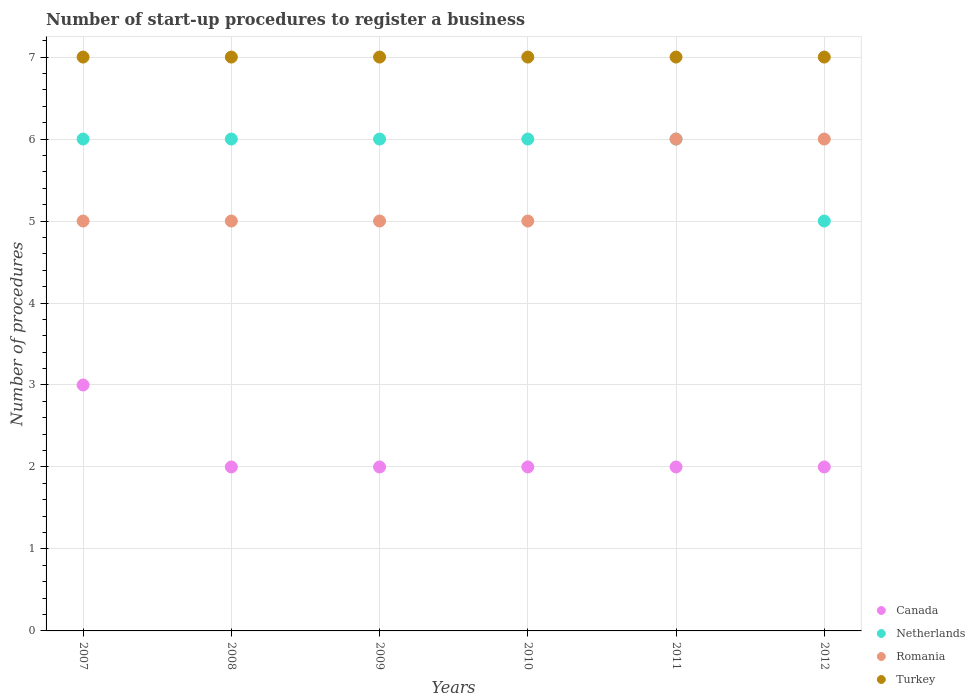How many different coloured dotlines are there?
Your answer should be very brief. 4. What is the number of procedures required to register a business in Netherlands in 2012?
Your answer should be very brief. 5. Across all years, what is the maximum number of procedures required to register a business in Canada?
Provide a succinct answer. 3. Across all years, what is the minimum number of procedures required to register a business in Canada?
Offer a terse response. 2. What is the total number of procedures required to register a business in Canada in the graph?
Keep it short and to the point. 13. What is the difference between the number of procedures required to register a business in Netherlands in 2008 and that in 2010?
Keep it short and to the point. 0. What is the difference between the number of procedures required to register a business in Romania in 2010 and the number of procedures required to register a business in Canada in 2008?
Offer a very short reply. 3. What is the average number of procedures required to register a business in Romania per year?
Ensure brevity in your answer.  5.33. In the year 2007, what is the difference between the number of procedures required to register a business in Netherlands and number of procedures required to register a business in Romania?
Provide a short and direct response. 1. In how many years, is the number of procedures required to register a business in Romania greater than 3.2?
Make the answer very short. 6. What is the ratio of the number of procedures required to register a business in Turkey in 2009 to that in 2012?
Your answer should be compact. 1. Is the number of procedures required to register a business in Romania in 2009 less than that in 2011?
Offer a terse response. Yes. Is the difference between the number of procedures required to register a business in Netherlands in 2009 and 2011 greater than the difference between the number of procedures required to register a business in Romania in 2009 and 2011?
Your answer should be very brief. Yes. What is the difference between the highest and the second highest number of procedures required to register a business in Turkey?
Make the answer very short. 0. What is the difference between the highest and the lowest number of procedures required to register a business in Canada?
Provide a short and direct response. 1. In how many years, is the number of procedures required to register a business in Canada greater than the average number of procedures required to register a business in Canada taken over all years?
Offer a terse response. 1. Is it the case that in every year, the sum of the number of procedures required to register a business in Romania and number of procedures required to register a business in Netherlands  is greater than the sum of number of procedures required to register a business in Turkey and number of procedures required to register a business in Canada?
Make the answer very short. No. Does the number of procedures required to register a business in Netherlands monotonically increase over the years?
Give a very brief answer. No. How many years are there in the graph?
Your answer should be very brief. 6. Are the values on the major ticks of Y-axis written in scientific E-notation?
Ensure brevity in your answer.  No. Does the graph contain any zero values?
Keep it short and to the point. No. Does the graph contain grids?
Your answer should be very brief. Yes. What is the title of the graph?
Give a very brief answer. Number of start-up procedures to register a business. Does "Congo (Republic)" appear as one of the legend labels in the graph?
Offer a very short reply. No. What is the label or title of the Y-axis?
Keep it short and to the point. Number of procedures. What is the Number of procedures in Netherlands in 2007?
Your answer should be very brief. 6. What is the Number of procedures in Turkey in 2007?
Offer a very short reply. 7. What is the Number of procedures of Canada in 2008?
Provide a succinct answer. 2. What is the Number of procedures of Turkey in 2008?
Make the answer very short. 7. What is the Number of procedures in Canada in 2009?
Ensure brevity in your answer.  2. What is the Number of procedures of Romania in 2009?
Give a very brief answer. 5. What is the Number of procedures of Romania in 2010?
Give a very brief answer. 5. What is the Number of procedures of Romania in 2011?
Make the answer very short. 6. What is the Number of procedures of Netherlands in 2012?
Provide a succinct answer. 5. Across all years, what is the maximum Number of procedures in Canada?
Your response must be concise. 3. Across all years, what is the maximum Number of procedures of Netherlands?
Your answer should be compact. 6. Across all years, what is the maximum Number of procedures in Romania?
Offer a terse response. 6. Across all years, what is the minimum Number of procedures of Canada?
Give a very brief answer. 2. Across all years, what is the minimum Number of procedures in Netherlands?
Your response must be concise. 5. Across all years, what is the minimum Number of procedures of Turkey?
Your response must be concise. 7. What is the total Number of procedures in Romania in the graph?
Your answer should be very brief. 32. What is the total Number of procedures of Turkey in the graph?
Your answer should be compact. 42. What is the difference between the Number of procedures in Romania in 2007 and that in 2008?
Your response must be concise. 0. What is the difference between the Number of procedures of Canada in 2007 and that in 2009?
Your answer should be very brief. 1. What is the difference between the Number of procedures of Netherlands in 2007 and that in 2009?
Ensure brevity in your answer.  0. What is the difference between the Number of procedures of Canada in 2007 and that in 2010?
Your answer should be very brief. 1. What is the difference between the Number of procedures of Romania in 2007 and that in 2010?
Provide a short and direct response. 0. What is the difference between the Number of procedures of Turkey in 2007 and that in 2010?
Make the answer very short. 0. What is the difference between the Number of procedures of Canada in 2007 and that in 2011?
Give a very brief answer. 1. What is the difference between the Number of procedures in Romania in 2007 and that in 2011?
Your answer should be very brief. -1. What is the difference between the Number of procedures in Canada in 2007 and that in 2012?
Offer a terse response. 1. What is the difference between the Number of procedures in Canada in 2008 and that in 2009?
Ensure brevity in your answer.  0. What is the difference between the Number of procedures of Romania in 2008 and that in 2009?
Provide a succinct answer. 0. What is the difference between the Number of procedures in Turkey in 2008 and that in 2009?
Keep it short and to the point. 0. What is the difference between the Number of procedures of Romania in 2008 and that in 2010?
Keep it short and to the point. 0. What is the difference between the Number of procedures in Canada in 2008 and that in 2011?
Your response must be concise. 0. What is the difference between the Number of procedures of Netherlands in 2008 and that in 2011?
Provide a short and direct response. 0. What is the difference between the Number of procedures in Canada in 2009 and that in 2010?
Your answer should be compact. 0. What is the difference between the Number of procedures of Turkey in 2009 and that in 2010?
Provide a succinct answer. 0. What is the difference between the Number of procedures in Canada in 2009 and that in 2011?
Offer a very short reply. 0. What is the difference between the Number of procedures in Netherlands in 2009 and that in 2011?
Offer a very short reply. 0. What is the difference between the Number of procedures of Romania in 2009 and that in 2011?
Your answer should be compact. -1. What is the difference between the Number of procedures of Turkey in 2009 and that in 2011?
Offer a terse response. 0. What is the difference between the Number of procedures of Canada in 2009 and that in 2012?
Offer a very short reply. 0. What is the difference between the Number of procedures of Netherlands in 2009 and that in 2012?
Ensure brevity in your answer.  1. What is the difference between the Number of procedures of Canada in 2010 and that in 2011?
Ensure brevity in your answer.  0. What is the difference between the Number of procedures in Romania in 2010 and that in 2011?
Make the answer very short. -1. What is the difference between the Number of procedures of Canada in 2010 and that in 2012?
Ensure brevity in your answer.  0. What is the difference between the Number of procedures of Romania in 2010 and that in 2012?
Offer a terse response. -1. What is the difference between the Number of procedures in Romania in 2011 and that in 2012?
Your answer should be compact. 0. What is the difference between the Number of procedures of Canada in 2007 and the Number of procedures of Turkey in 2008?
Provide a succinct answer. -4. What is the difference between the Number of procedures of Netherlands in 2007 and the Number of procedures of Romania in 2008?
Your answer should be compact. 1. What is the difference between the Number of procedures of Canada in 2007 and the Number of procedures of Romania in 2009?
Give a very brief answer. -2. What is the difference between the Number of procedures of Netherlands in 2007 and the Number of procedures of Romania in 2009?
Provide a succinct answer. 1. What is the difference between the Number of procedures in Netherlands in 2007 and the Number of procedures in Turkey in 2009?
Your answer should be very brief. -1. What is the difference between the Number of procedures of Canada in 2007 and the Number of procedures of Netherlands in 2010?
Offer a terse response. -3. What is the difference between the Number of procedures of Netherlands in 2007 and the Number of procedures of Romania in 2010?
Keep it short and to the point. 1. What is the difference between the Number of procedures of Romania in 2007 and the Number of procedures of Turkey in 2010?
Keep it short and to the point. -2. What is the difference between the Number of procedures in Canada in 2007 and the Number of procedures in Netherlands in 2011?
Provide a short and direct response. -3. What is the difference between the Number of procedures in Canada in 2007 and the Number of procedures in Romania in 2011?
Provide a succinct answer. -3. What is the difference between the Number of procedures in Canada in 2007 and the Number of procedures in Turkey in 2011?
Your answer should be very brief. -4. What is the difference between the Number of procedures in Netherlands in 2007 and the Number of procedures in Turkey in 2011?
Make the answer very short. -1. What is the difference between the Number of procedures in Romania in 2007 and the Number of procedures in Turkey in 2011?
Keep it short and to the point. -2. What is the difference between the Number of procedures in Canada in 2007 and the Number of procedures in Netherlands in 2012?
Your response must be concise. -2. What is the difference between the Number of procedures of Canada in 2007 and the Number of procedures of Romania in 2012?
Make the answer very short. -3. What is the difference between the Number of procedures of Netherlands in 2007 and the Number of procedures of Romania in 2012?
Offer a very short reply. 0. What is the difference between the Number of procedures in Romania in 2007 and the Number of procedures in Turkey in 2012?
Ensure brevity in your answer.  -2. What is the difference between the Number of procedures in Canada in 2008 and the Number of procedures in Romania in 2009?
Ensure brevity in your answer.  -3. What is the difference between the Number of procedures in Netherlands in 2008 and the Number of procedures in Romania in 2009?
Offer a very short reply. 1. What is the difference between the Number of procedures of Netherlands in 2008 and the Number of procedures of Turkey in 2009?
Offer a very short reply. -1. What is the difference between the Number of procedures of Romania in 2008 and the Number of procedures of Turkey in 2009?
Keep it short and to the point. -2. What is the difference between the Number of procedures in Netherlands in 2008 and the Number of procedures in Romania in 2010?
Ensure brevity in your answer.  1. What is the difference between the Number of procedures in Netherlands in 2008 and the Number of procedures in Turkey in 2010?
Keep it short and to the point. -1. What is the difference between the Number of procedures in Romania in 2008 and the Number of procedures in Turkey in 2010?
Your response must be concise. -2. What is the difference between the Number of procedures of Canada in 2008 and the Number of procedures of Netherlands in 2011?
Keep it short and to the point. -4. What is the difference between the Number of procedures of Canada in 2008 and the Number of procedures of Romania in 2011?
Your response must be concise. -4. What is the difference between the Number of procedures of Canada in 2008 and the Number of procedures of Turkey in 2011?
Provide a short and direct response. -5. What is the difference between the Number of procedures in Romania in 2008 and the Number of procedures in Turkey in 2011?
Provide a short and direct response. -2. What is the difference between the Number of procedures in Netherlands in 2008 and the Number of procedures in Romania in 2012?
Your answer should be compact. 0. What is the difference between the Number of procedures of Netherlands in 2008 and the Number of procedures of Turkey in 2012?
Provide a short and direct response. -1. What is the difference between the Number of procedures of Canada in 2009 and the Number of procedures of Netherlands in 2010?
Ensure brevity in your answer.  -4. What is the difference between the Number of procedures in Canada in 2009 and the Number of procedures in Romania in 2010?
Offer a terse response. -3. What is the difference between the Number of procedures of Canada in 2009 and the Number of procedures of Netherlands in 2011?
Offer a terse response. -4. What is the difference between the Number of procedures in Canada in 2009 and the Number of procedures in Romania in 2011?
Your answer should be very brief. -4. What is the difference between the Number of procedures in Netherlands in 2009 and the Number of procedures in Turkey in 2011?
Your answer should be very brief. -1. What is the difference between the Number of procedures of Canada in 2009 and the Number of procedures of Romania in 2012?
Make the answer very short. -4. What is the difference between the Number of procedures in Netherlands in 2009 and the Number of procedures in Romania in 2012?
Provide a succinct answer. 0. What is the difference between the Number of procedures of Canada in 2010 and the Number of procedures of Netherlands in 2011?
Offer a very short reply. -4. What is the difference between the Number of procedures in Canada in 2010 and the Number of procedures in Romania in 2011?
Your answer should be very brief. -4. What is the difference between the Number of procedures of Romania in 2010 and the Number of procedures of Turkey in 2011?
Offer a terse response. -2. What is the difference between the Number of procedures in Canada in 2010 and the Number of procedures in Romania in 2012?
Your response must be concise. -4. What is the difference between the Number of procedures of Netherlands in 2010 and the Number of procedures of Turkey in 2012?
Offer a terse response. -1. What is the difference between the Number of procedures in Canada in 2011 and the Number of procedures in Netherlands in 2012?
Give a very brief answer. -3. What is the difference between the Number of procedures in Canada in 2011 and the Number of procedures in Romania in 2012?
Offer a very short reply. -4. What is the difference between the Number of procedures of Netherlands in 2011 and the Number of procedures of Turkey in 2012?
Your response must be concise. -1. What is the average Number of procedures of Canada per year?
Provide a short and direct response. 2.17. What is the average Number of procedures in Netherlands per year?
Your answer should be compact. 5.83. What is the average Number of procedures in Romania per year?
Offer a terse response. 5.33. In the year 2007, what is the difference between the Number of procedures of Canada and Number of procedures of Netherlands?
Provide a succinct answer. -3. In the year 2007, what is the difference between the Number of procedures in Netherlands and Number of procedures in Romania?
Offer a terse response. 1. In the year 2007, what is the difference between the Number of procedures in Netherlands and Number of procedures in Turkey?
Keep it short and to the point. -1. In the year 2007, what is the difference between the Number of procedures of Romania and Number of procedures of Turkey?
Provide a succinct answer. -2. In the year 2008, what is the difference between the Number of procedures in Netherlands and Number of procedures in Romania?
Your response must be concise. 1. In the year 2009, what is the difference between the Number of procedures in Canada and Number of procedures in Netherlands?
Your answer should be very brief. -4. In the year 2009, what is the difference between the Number of procedures of Canada and Number of procedures of Romania?
Ensure brevity in your answer.  -3. In the year 2009, what is the difference between the Number of procedures in Canada and Number of procedures in Turkey?
Ensure brevity in your answer.  -5. In the year 2009, what is the difference between the Number of procedures in Netherlands and Number of procedures in Romania?
Your response must be concise. 1. In the year 2009, what is the difference between the Number of procedures of Netherlands and Number of procedures of Turkey?
Your answer should be very brief. -1. In the year 2009, what is the difference between the Number of procedures in Romania and Number of procedures in Turkey?
Your answer should be very brief. -2. In the year 2010, what is the difference between the Number of procedures in Canada and Number of procedures in Romania?
Keep it short and to the point. -3. In the year 2010, what is the difference between the Number of procedures of Canada and Number of procedures of Turkey?
Offer a terse response. -5. In the year 2010, what is the difference between the Number of procedures of Netherlands and Number of procedures of Romania?
Make the answer very short. 1. In the year 2010, what is the difference between the Number of procedures of Netherlands and Number of procedures of Turkey?
Make the answer very short. -1. In the year 2010, what is the difference between the Number of procedures of Romania and Number of procedures of Turkey?
Ensure brevity in your answer.  -2. In the year 2011, what is the difference between the Number of procedures of Canada and Number of procedures of Netherlands?
Your answer should be very brief. -4. In the year 2011, what is the difference between the Number of procedures in Canada and Number of procedures in Romania?
Keep it short and to the point. -4. In the year 2011, what is the difference between the Number of procedures of Netherlands and Number of procedures of Romania?
Provide a short and direct response. 0. In the year 2011, what is the difference between the Number of procedures in Netherlands and Number of procedures in Turkey?
Offer a very short reply. -1. In the year 2012, what is the difference between the Number of procedures in Canada and Number of procedures in Romania?
Offer a terse response. -4. In the year 2012, what is the difference between the Number of procedures of Canada and Number of procedures of Turkey?
Offer a terse response. -5. In the year 2012, what is the difference between the Number of procedures in Netherlands and Number of procedures in Romania?
Ensure brevity in your answer.  -1. In the year 2012, what is the difference between the Number of procedures of Netherlands and Number of procedures of Turkey?
Keep it short and to the point. -2. In the year 2012, what is the difference between the Number of procedures in Romania and Number of procedures in Turkey?
Provide a short and direct response. -1. What is the ratio of the Number of procedures of Netherlands in 2007 to that in 2008?
Your answer should be very brief. 1. What is the ratio of the Number of procedures of Turkey in 2007 to that in 2008?
Make the answer very short. 1. What is the ratio of the Number of procedures of Netherlands in 2007 to that in 2009?
Offer a very short reply. 1. What is the ratio of the Number of procedures in Romania in 2007 to that in 2009?
Your answer should be very brief. 1. What is the ratio of the Number of procedures of Romania in 2007 to that in 2010?
Your answer should be very brief. 1. What is the ratio of the Number of procedures of Canada in 2007 to that in 2011?
Provide a succinct answer. 1.5. What is the ratio of the Number of procedures of Netherlands in 2007 to that in 2011?
Your answer should be compact. 1. What is the ratio of the Number of procedures of Canada in 2007 to that in 2012?
Provide a short and direct response. 1.5. What is the ratio of the Number of procedures of Netherlands in 2007 to that in 2012?
Keep it short and to the point. 1.2. What is the ratio of the Number of procedures in Romania in 2007 to that in 2012?
Ensure brevity in your answer.  0.83. What is the ratio of the Number of procedures in Netherlands in 2008 to that in 2009?
Give a very brief answer. 1. What is the ratio of the Number of procedures of Turkey in 2008 to that in 2010?
Give a very brief answer. 1. What is the ratio of the Number of procedures in Romania in 2008 to that in 2011?
Provide a short and direct response. 0.83. What is the ratio of the Number of procedures of Turkey in 2008 to that in 2011?
Make the answer very short. 1. What is the ratio of the Number of procedures of Canada in 2008 to that in 2012?
Offer a terse response. 1. What is the ratio of the Number of procedures of Netherlands in 2008 to that in 2012?
Provide a succinct answer. 1.2. What is the ratio of the Number of procedures of Turkey in 2008 to that in 2012?
Your answer should be compact. 1. What is the ratio of the Number of procedures in Romania in 2009 to that in 2010?
Keep it short and to the point. 1. What is the ratio of the Number of procedures in Canada in 2009 to that in 2011?
Provide a succinct answer. 1. What is the ratio of the Number of procedures in Netherlands in 2009 to that in 2011?
Ensure brevity in your answer.  1. What is the ratio of the Number of procedures in Turkey in 2009 to that in 2011?
Provide a short and direct response. 1. What is the ratio of the Number of procedures in Netherlands in 2009 to that in 2012?
Keep it short and to the point. 1.2. What is the ratio of the Number of procedures of Netherlands in 2010 to that in 2011?
Ensure brevity in your answer.  1. What is the ratio of the Number of procedures in Romania in 2010 to that in 2011?
Provide a short and direct response. 0.83. What is the ratio of the Number of procedures in Turkey in 2010 to that in 2011?
Your response must be concise. 1. What is the ratio of the Number of procedures in Netherlands in 2010 to that in 2012?
Keep it short and to the point. 1.2. What is the ratio of the Number of procedures of Turkey in 2010 to that in 2012?
Make the answer very short. 1. What is the ratio of the Number of procedures of Canada in 2011 to that in 2012?
Provide a succinct answer. 1. What is the ratio of the Number of procedures of Netherlands in 2011 to that in 2012?
Make the answer very short. 1.2. What is the difference between the highest and the second highest Number of procedures of Canada?
Ensure brevity in your answer.  1. What is the difference between the highest and the second highest Number of procedures in Romania?
Your answer should be compact. 0. What is the difference between the highest and the lowest Number of procedures of Netherlands?
Offer a very short reply. 1. What is the difference between the highest and the lowest Number of procedures of Turkey?
Offer a very short reply. 0. 